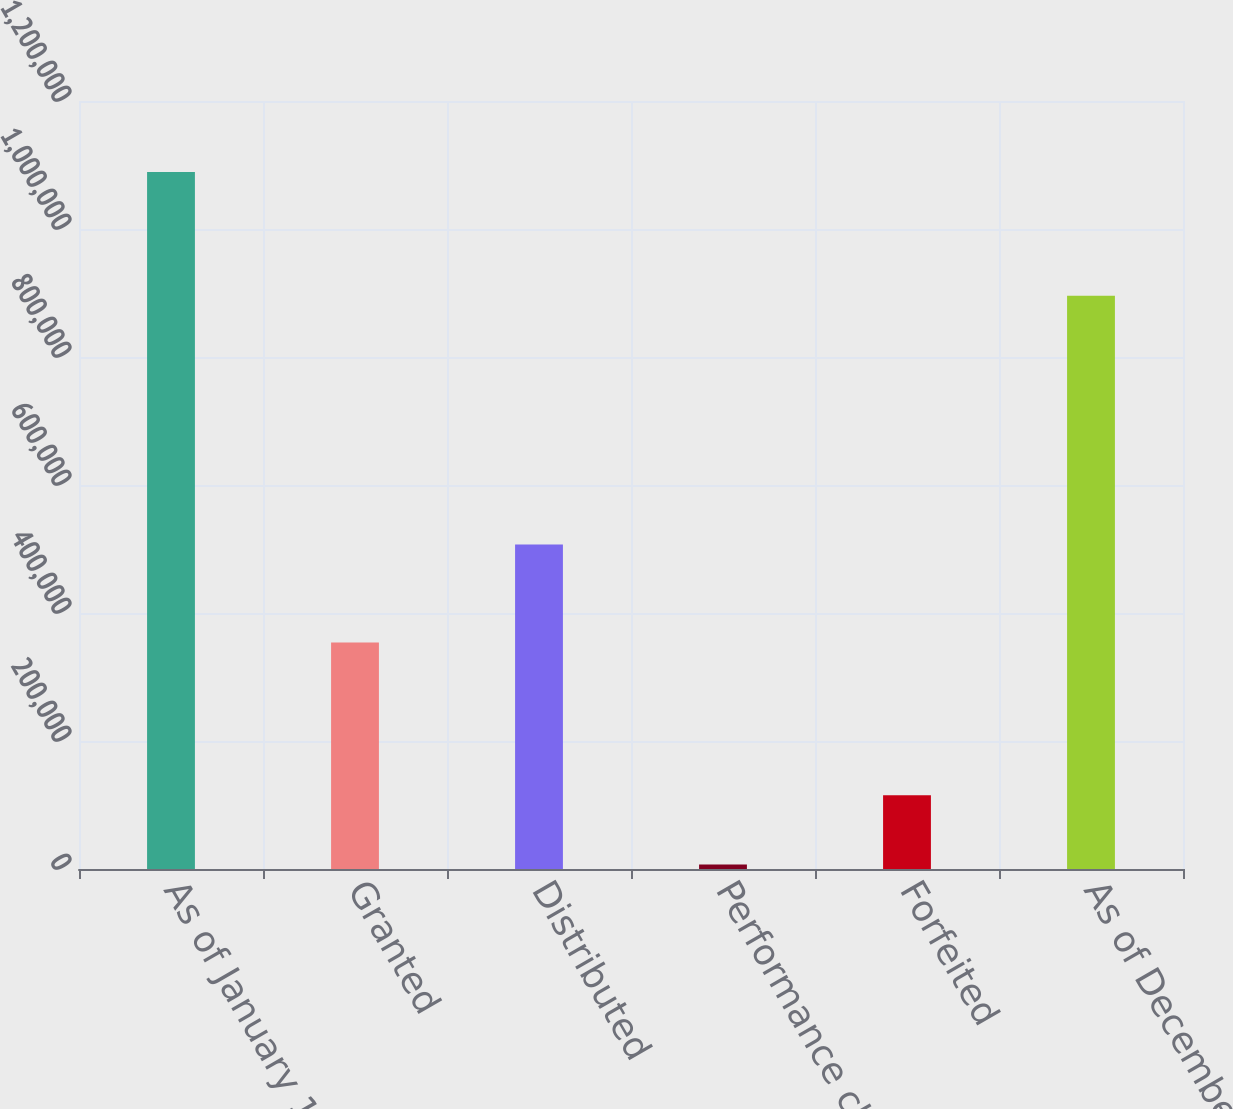Convert chart to OTSL. <chart><loc_0><loc_0><loc_500><loc_500><bar_chart><fcel>As of January 1<fcel>Granted<fcel>Distributed<fcel>Performance change<fcel>Forfeited<fcel>As of December 31<nl><fcel>1.08908e+06<fcel>353734<fcel>507083<fcel>6949<fcel>115162<fcel>895635<nl></chart> 